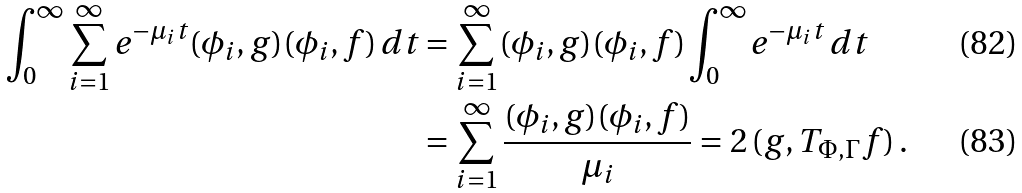Convert formula to latex. <formula><loc_0><loc_0><loc_500><loc_500>\int _ { 0 } ^ { \infty } \sum _ { i = 1 } ^ { \infty } e ^ { - \mu _ { i } t } ( \phi _ { i } , g ) ( \phi _ { i } , f ) \, d t & = \sum _ { i = 1 } ^ { \infty } ( \phi _ { i } , g ) ( \phi _ { i } , f ) \int _ { 0 } ^ { \infty } e ^ { - \mu _ { i } t } \, d t \\ & = \sum _ { i = 1 } ^ { \infty } \frac { ( \phi _ { i } , g ) ( \phi _ { i } , f ) } { \mu _ { i } } = 2 \, ( g , T _ { \Phi , \Gamma } f ) \, .</formula> 